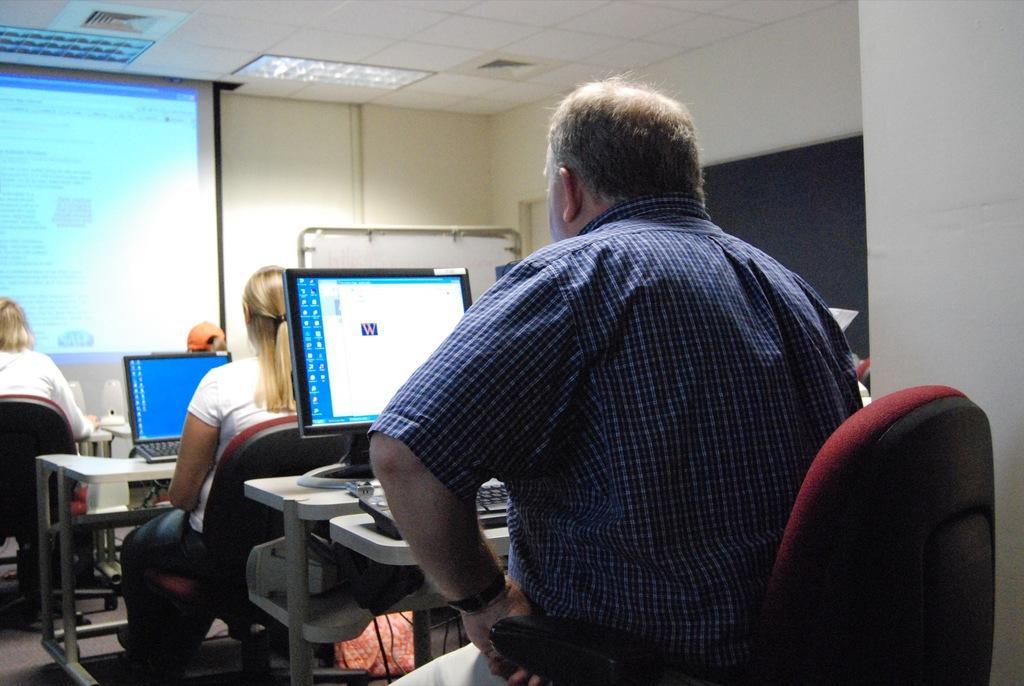Please provide a concise description of this image. People are sitting in chairs and working with desktops in front them. 